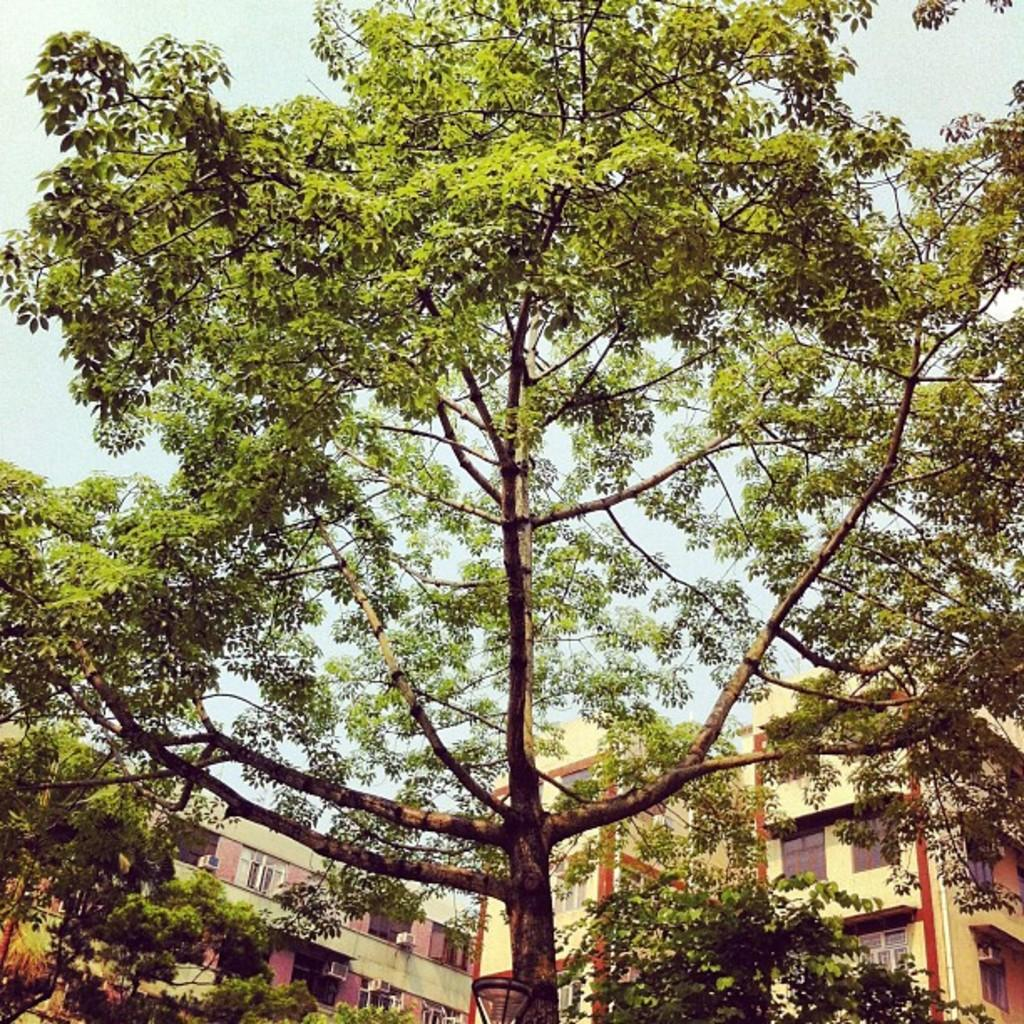What type of structures can be seen in the image? There are many buildings in the image. What other elements can be found in the image besides buildings? There are trees in the image. How many jellyfish can be seen swimming in the trees in the image? There are no jellyfish present in the image, and jellyfish cannot swim in trees. 